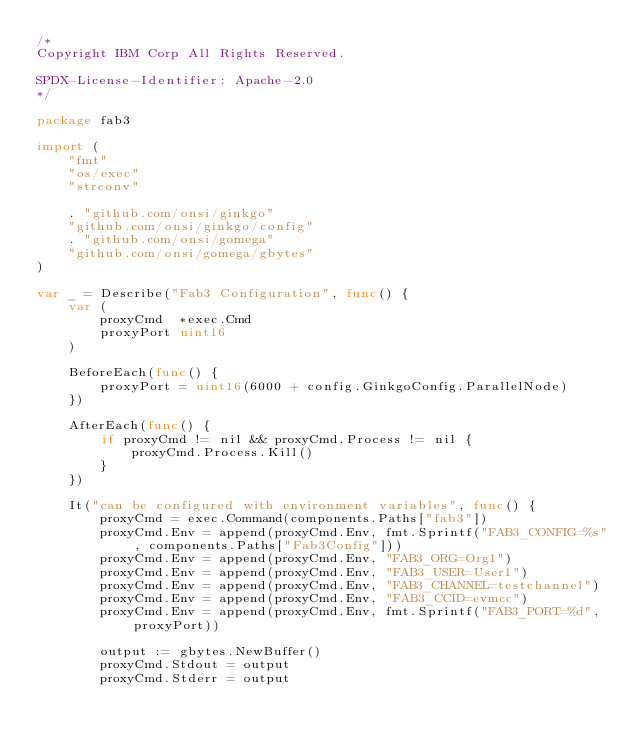Convert code to text. <code><loc_0><loc_0><loc_500><loc_500><_Go_>/*
Copyright IBM Corp All Rights Reserved.

SPDX-License-Identifier: Apache-2.0
*/

package fab3

import (
	"fmt"
	"os/exec"
	"strconv"

	. "github.com/onsi/ginkgo"
	"github.com/onsi/ginkgo/config"
	. "github.com/onsi/gomega"
	"github.com/onsi/gomega/gbytes"
)

var _ = Describe("Fab3 Configuration", func() {
	var (
		proxyCmd  *exec.Cmd
		proxyPort uint16
	)

	BeforeEach(func() {
		proxyPort = uint16(6000 + config.GinkgoConfig.ParallelNode)
	})

	AfterEach(func() {
		if proxyCmd != nil && proxyCmd.Process != nil {
			proxyCmd.Process.Kill()
		}
	})

	It("can be configured with environment variables", func() {
		proxyCmd = exec.Command(components.Paths["fab3"])
		proxyCmd.Env = append(proxyCmd.Env, fmt.Sprintf("FAB3_CONFIG=%s", components.Paths["Fab3Config"]))
		proxyCmd.Env = append(proxyCmd.Env, "FAB3_ORG=Org1")
		proxyCmd.Env = append(proxyCmd.Env, "FAB3_USER=User1")
		proxyCmd.Env = append(proxyCmd.Env, "FAB3_CHANNEL=testchannel")
		proxyCmd.Env = append(proxyCmd.Env, "FAB3_CCID=evmcc")
		proxyCmd.Env = append(proxyCmd.Env, fmt.Sprintf("FAB3_PORT=%d", proxyPort))

		output := gbytes.NewBuffer()
		proxyCmd.Stdout = output
		proxyCmd.Stderr = output
</code> 